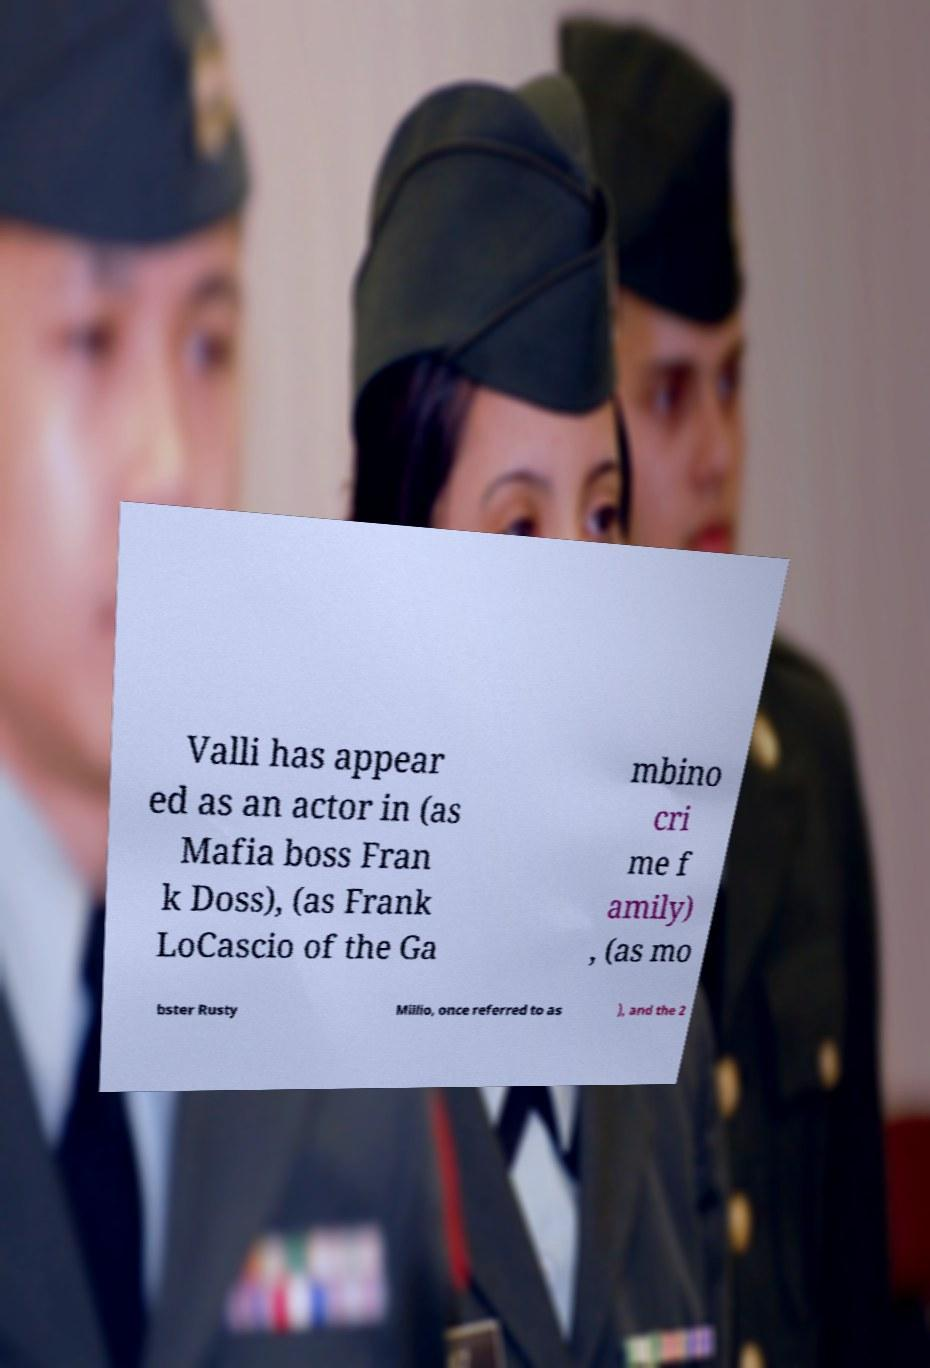What messages or text are displayed in this image? I need them in a readable, typed format. Valli has appear ed as an actor in (as Mafia boss Fran k Doss), (as Frank LoCascio of the Ga mbino cri me f amily) , (as mo bster Rusty Millio, once referred to as ), and the 2 